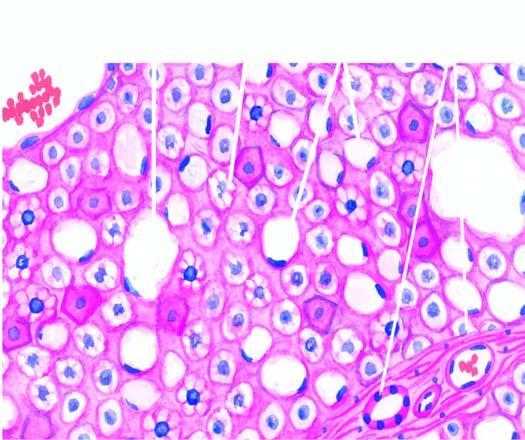what are many of the hepatocytes distended with pushing the nuclei to the periphery macrovesicles, while others show multiple small vacuoles in the cytoplasm microvesicles?
Answer the question using a single word or phrase. Large fat 